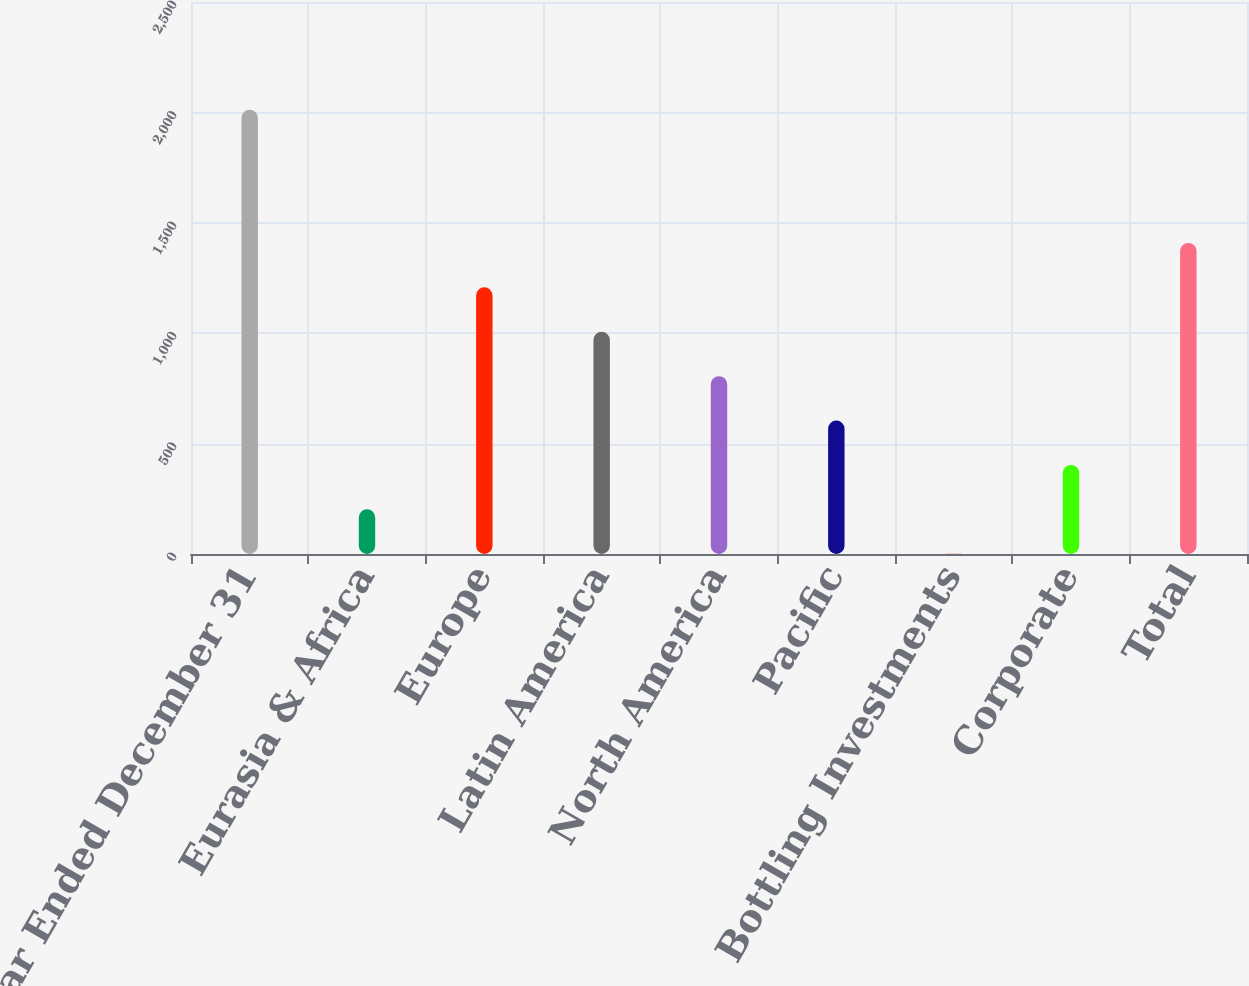Convert chart to OTSL. <chart><loc_0><loc_0><loc_500><loc_500><bar_chart><fcel>Year Ended December 31<fcel>Eurasia & Africa<fcel>Europe<fcel>Latin America<fcel>North America<fcel>Pacific<fcel>Bottling Investments<fcel>Corporate<fcel>Total<nl><fcel>2012<fcel>202.37<fcel>1207.72<fcel>1006.65<fcel>805.58<fcel>604.51<fcel>1.3<fcel>403.44<fcel>1408.79<nl></chart> 